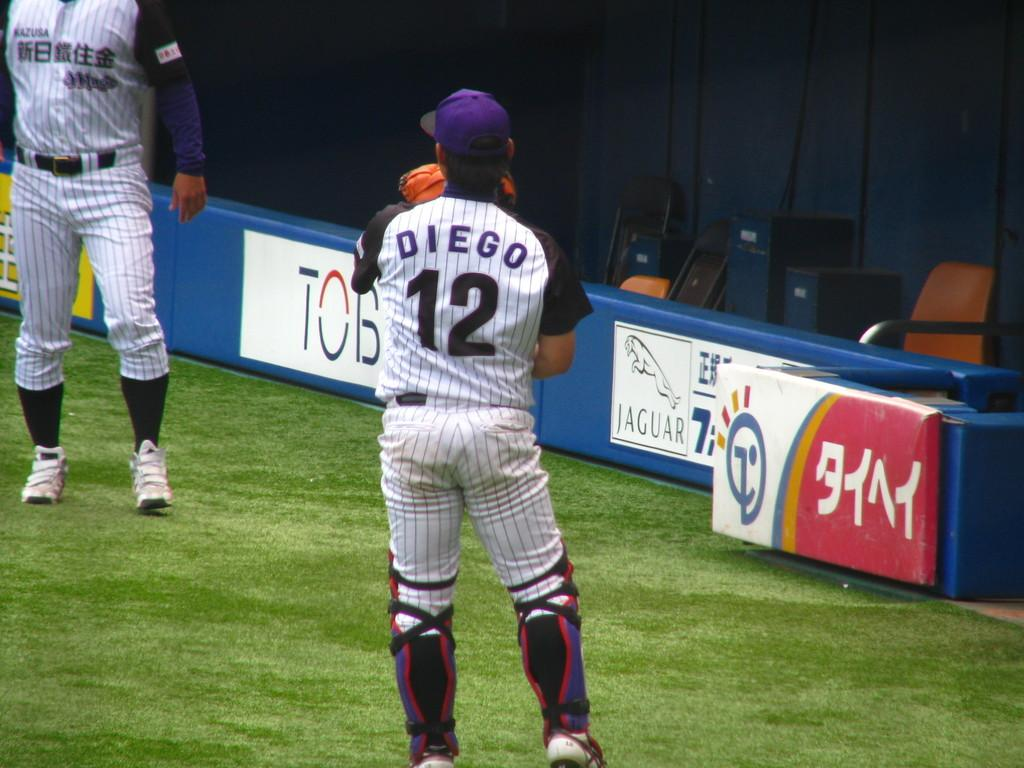<image>
Create a compact narrative representing the image presented. A player named Diego wearing jersey number 12 